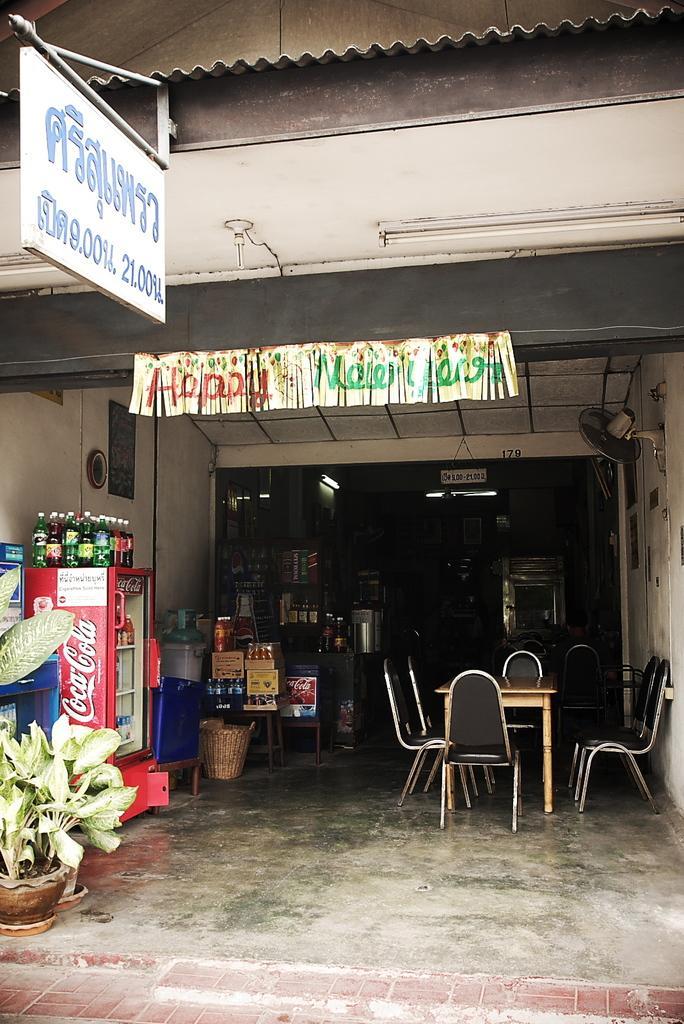Please provide a concise description of this image. In this image we can see a shop and banner. Inside the shop things are present. And table and chairs are there. Left side of the image bottles, fridge and plants are there. 